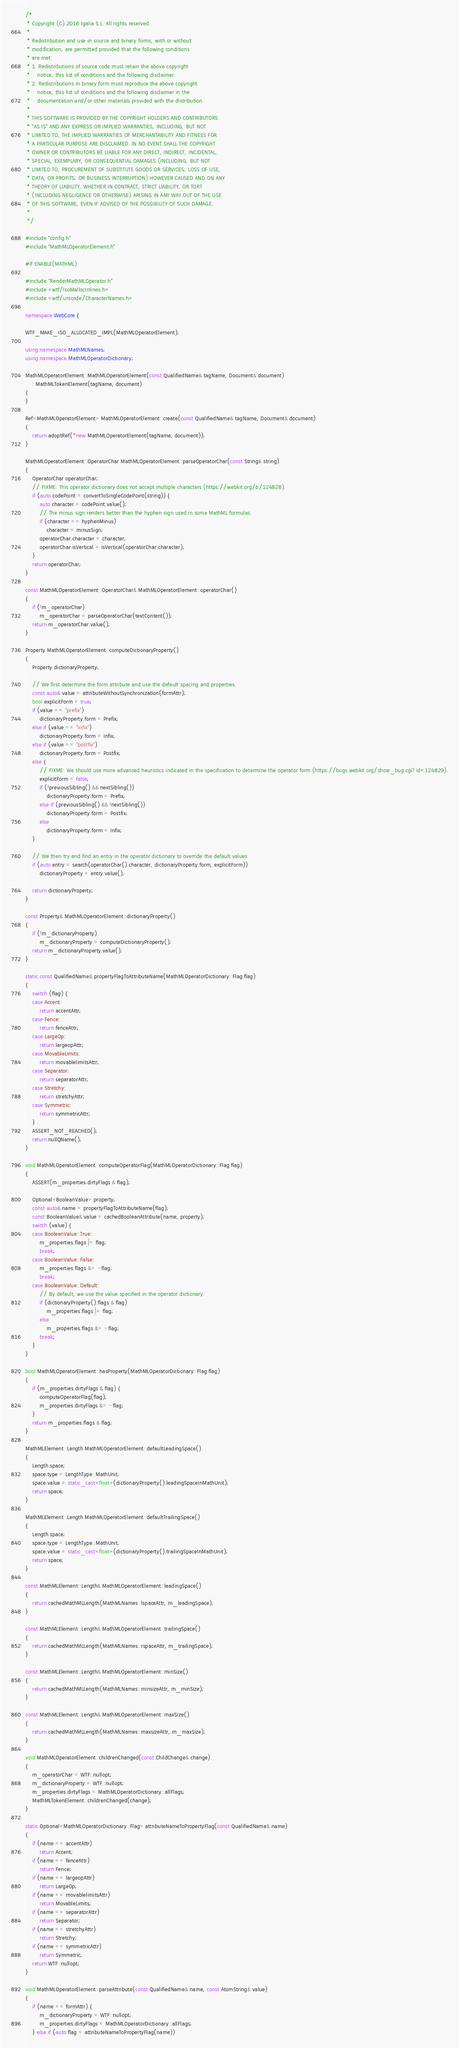Convert code to text. <code><loc_0><loc_0><loc_500><loc_500><_C++_>/*
 * Copyright (C) 2016 Igalia S.L. All rights reserved.
 *
 * Redistribution and use in source and binary forms, with or without
 * modification, are permitted provided that the following conditions
 * are met:
 * 1. Redistributions of source code must retain the above copyright
 *    notice, this list of conditions and the following disclaimer.
 * 2. Redistributions in binary form must reproduce the above copyright
 *    notice, this list of conditions and the following disclaimer in the
 *    documentation and/or other materials provided with the distribution.
 *
 * THIS SOFTWARE IS PROVIDED BY THE COPYRIGHT HOLDERS AND CONTRIBUTORS
 * "AS IS" AND ANY EXPRESS OR IMPLIED WARRANTIES, INCLUDING, BUT NOT
 * LIMITED TO, THE IMPLIED WARRANTIES OF MERCHANTABILITY AND FITNESS FOR
 * A PARTICULAR PURPOSE ARE DISCLAIMED. IN NO EVENT SHALL THE COPYRIGHT
 * OWNER OR CONTRIBUTORS BE LIABLE FOR ANY DIRECT, INDIRECT, INCIDENTAL,
 * SPECIAL, EXEMPLARY, OR CONSEQUENTIAL DAMAGES (INCLUDING, BUT NOT
 * LIMITED TO, PROCUREMENT OF SUBSTITUTE GOODS OR SERVICES; LOSS OF USE,
 * DATA, OR PROFITS; OR BUSINESS INTERRUPTION) HOWEVER CAUSED AND ON ANY
 * THEORY OF LIABILITY, WHETHER IN CONTRACT, STRICT LIABILITY, OR TORT
 * (INCLUDING NEGLIGENCE OR OTHERWISE) ARISING IN ANY WAY OUT OF THE USE
 * OF THIS SOFTWARE, EVEN IF ADVISED OF THE POSSIBILITY OF SUCH DAMAGE.
 *
 */

#include "config.h"
#include "MathMLOperatorElement.h"

#if ENABLE(MATHML)

#include "RenderMathMLOperator.h"
#include <wtf/IsoMallocInlines.h>
#include <wtf/unicode/CharacterNames.h>

namespace WebCore {

WTF_MAKE_ISO_ALLOCATED_IMPL(MathMLOperatorElement);

using namespace MathMLNames;
using namespace MathMLOperatorDictionary;

MathMLOperatorElement::MathMLOperatorElement(const QualifiedName& tagName, Document& document)
    : MathMLTokenElement(tagName, document)
{
}

Ref<MathMLOperatorElement> MathMLOperatorElement::create(const QualifiedName& tagName, Document& document)
{
    return adoptRef(*new MathMLOperatorElement(tagName, document));
}

MathMLOperatorElement::OperatorChar MathMLOperatorElement::parseOperatorChar(const String& string)
{
    OperatorChar operatorChar;
    // FIXME: This operator dictionary does not accept multiple characters (https://webkit.org/b/124828).
    if (auto codePoint = convertToSingleCodePoint(string)) {
        auto character = codePoint.value();
        // The minus sign renders better than the hyphen sign used in some MathML formulas.
        if (character == hyphenMinus)
            character = minusSign;
        operatorChar.character = character;
        operatorChar.isVertical = isVertical(operatorChar.character);
    }
    return operatorChar;
}

const MathMLOperatorElement::OperatorChar& MathMLOperatorElement::operatorChar()
{
    if (!m_operatorChar)
        m_operatorChar = parseOperatorChar(textContent());
    return m_operatorChar.value();
}

Property MathMLOperatorElement::computeDictionaryProperty()
{
    Property dictionaryProperty;

    // We first determine the form attribute and use the default spacing and properties.
    const auto& value = attributeWithoutSynchronization(formAttr);
    bool explicitForm = true;
    if (value == "prefix")
        dictionaryProperty.form = Prefix;
    else if (value == "infix")
        dictionaryProperty.form = Infix;
    else if (value == "postfix")
        dictionaryProperty.form = Postfix;
    else {
        // FIXME: We should use more advanced heuristics indicated in the specification to determine the operator form (https://bugs.webkit.org/show_bug.cgi?id=124829).
        explicitForm = false;
        if (!previousSibling() && nextSibling())
            dictionaryProperty.form = Prefix;
        else if (previousSibling() && !nextSibling())
            dictionaryProperty.form = Postfix;
        else
            dictionaryProperty.form = Infix;
    }

    // We then try and find an entry in the operator dictionary to override the default values.
    if (auto entry = search(operatorChar().character, dictionaryProperty.form, explicitForm))
        dictionaryProperty = entry.value();

    return dictionaryProperty;
}

const Property& MathMLOperatorElement::dictionaryProperty()
{
    if (!m_dictionaryProperty)
        m_dictionaryProperty = computeDictionaryProperty();
    return m_dictionaryProperty.value();
}

static const QualifiedName& propertyFlagToAttributeName(MathMLOperatorDictionary::Flag flag)
{
    switch (flag) {
    case Accent:
        return accentAttr;
    case Fence:
        return fenceAttr;
    case LargeOp:
        return largeopAttr;
    case MovableLimits:
        return movablelimitsAttr;
    case Separator:
        return separatorAttr;
    case Stretchy:
        return stretchyAttr;
    case Symmetric:
        return symmetricAttr;
    }
    ASSERT_NOT_REACHED();
    return nullQName();
}

void MathMLOperatorElement::computeOperatorFlag(MathMLOperatorDictionary::Flag flag)
{
    ASSERT(m_properties.dirtyFlags & flag);

    Optional<BooleanValue> property;
    const auto& name = propertyFlagToAttributeName(flag);
    const BooleanValue& value = cachedBooleanAttribute(name, property);
    switch (value) {
    case BooleanValue::True:
        m_properties.flags |= flag;
        break;
    case BooleanValue::False:
        m_properties.flags &= ~flag;
        break;
    case BooleanValue::Default:
        // By default, we use the value specified in the operator dictionary.
        if (dictionaryProperty().flags & flag)
            m_properties.flags |= flag;
        else
            m_properties.flags &= ~flag;
        break;
    }
}

bool MathMLOperatorElement::hasProperty(MathMLOperatorDictionary::Flag flag)
{
    if (m_properties.dirtyFlags & flag) {
        computeOperatorFlag(flag);
        m_properties.dirtyFlags &= ~flag;
    }
    return m_properties.flags & flag;
}

MathMLElement::Length MathMLOperatorElement::defaultLeadingSpace()
{
    Length space;
    space.type = LengthType::MathUnit;
    space.value = static_cast<float>(dictionaryProperty().leadingSpaceInMathUnit);
    return space;
}

MathMLElement::Length MathMLOperatorElement::defaultTrailingSpace()
{
    Length space;
    space.type = LengthType::MathUnit;
    space.value = static_cast<float>(dictionaryProperty().trailingSpaceInMathUnit);
    return space;
}

const MathMLElement::Length& MathMLOperatorElement::leadingSpace()
{
    return cachedMathMLLength(MathMLNames::lspaceAttr, m_leadingSpace);
}

const MathMLElement::Length& MathMLOperatorElement::trailingSpace()
{
    return cachedMathMLLength(MathMLNames::rspaceAttr, m_trailingSpace);
}

const MathMLElement::Length& MathMLOperatorElement::minSize()
{
    return cachedMathMLLength(MathMLNames::minsizeAttr, m_minSize);
}

const MathMLElement::Length& MathMLOperatorElement::maxSize()
{
    return cachedMathMLLength(MathMLNames::maxsizeAttr, m_maxSize);
}

void MathMLOperatorElement::childrenChanged(const ChildChange& change)
{
    m_operatorChar = WTF::nullopt;
    m_dictionaryProperty = WTF::nullopt;
    m_properties.dirtyFlags = MathMLOperatorDictionary::allFlags;
    MathMLTokenElement::childrenChanged(change);
}

static Optional<MathMLOperatorDictionary::Flag> attributeNameToPropertyFlag(const QualifiedName& name)
{
    if (name == accentAttr)
        return Accent;
    if (name == fenceAttr)
        return Fence;
    if (name == largeopAttr)
        return LargeOp;
    if (name == movablelimitsAttr)
        return MovableLimits;
    if (name == separatorAttr)
        return Separator;
    if (name == stretchyAttr)
        return Stretchy;
    if (name == symmetricAttr)
        return Symmetric;
    return WTF::nullopt;
}

void MathMLOperatorElement::parseAttribute(const QualifiedName& name, const AtomString& value)
{
    if (name == formAttr) {
        m_dictionaryProperty = WTF::nullopt;
        m_properties.dirtyFlags = MathMLOperatorDictionary::allFlags;
    } else if (auto flag = attributeNameToPropertyFlag(name))</code> 